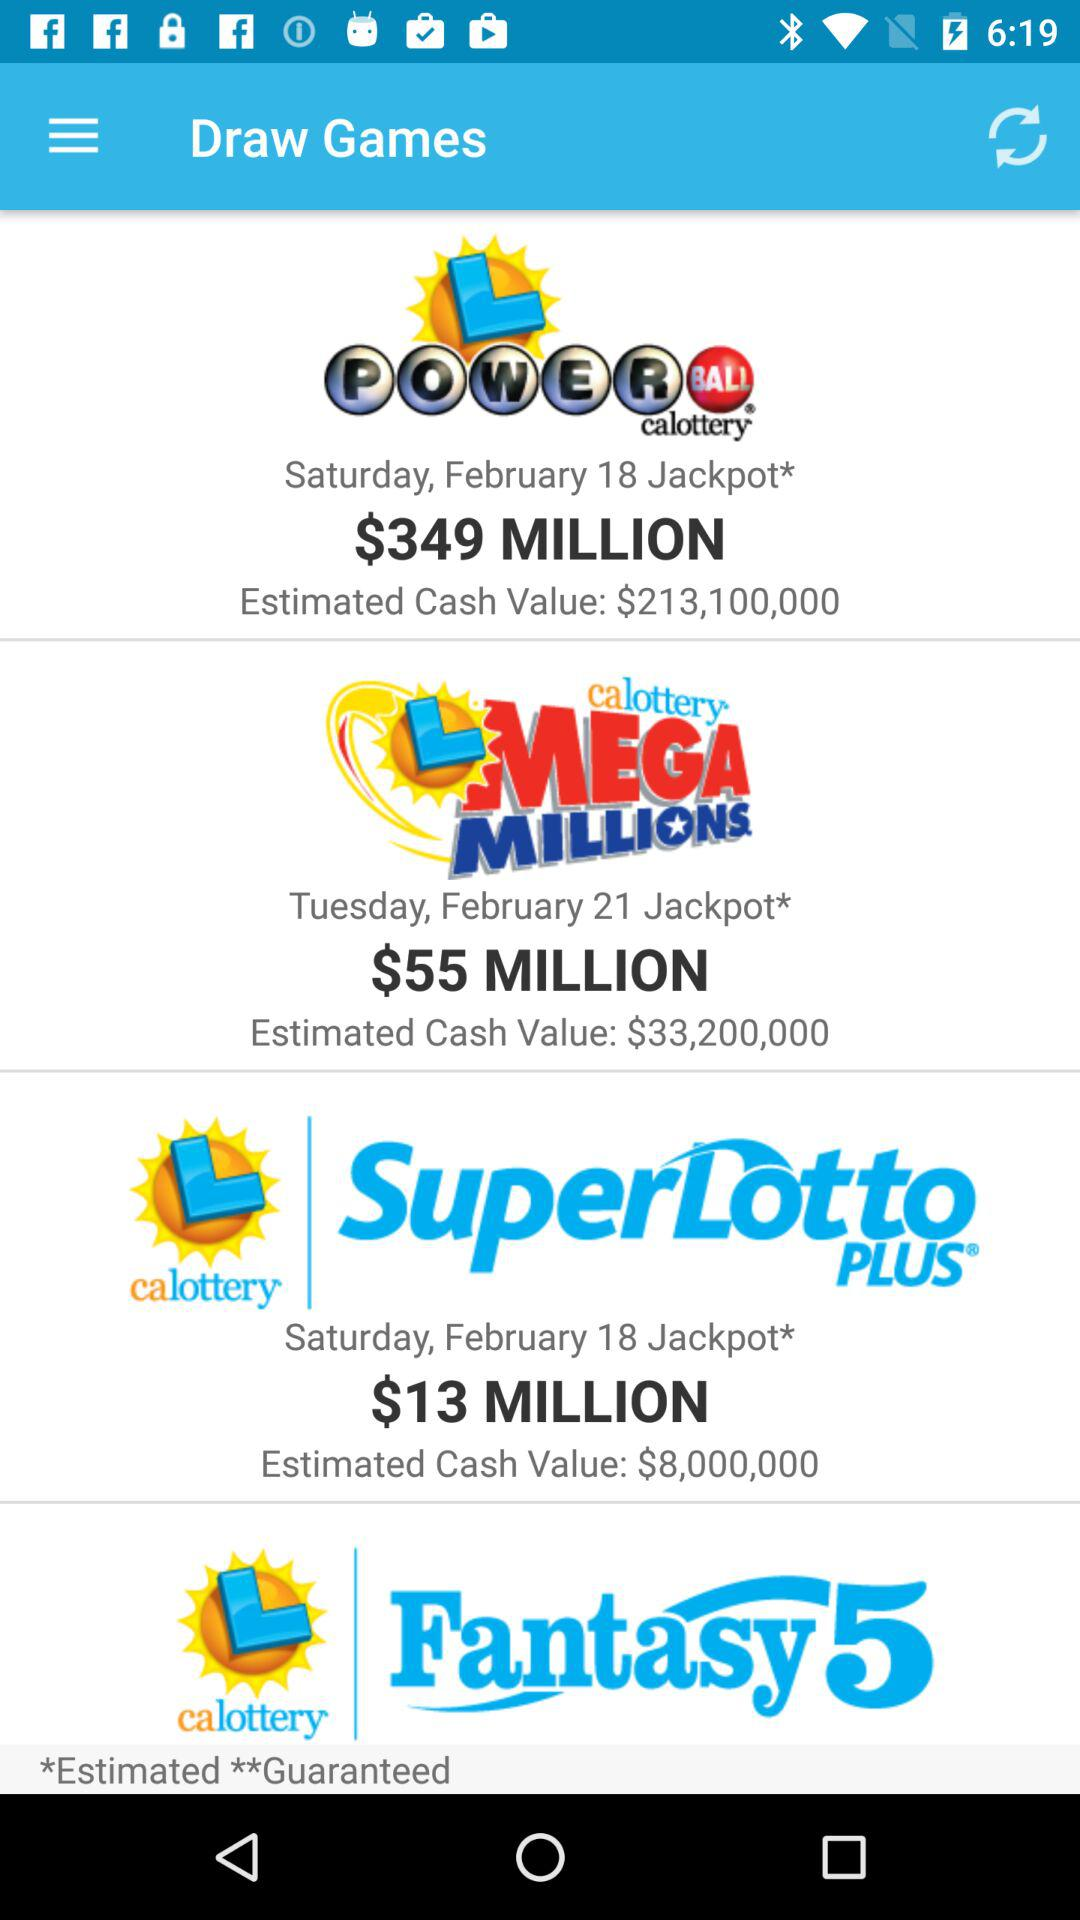What is the day on February 18? The day on February 18 is Saturday. 